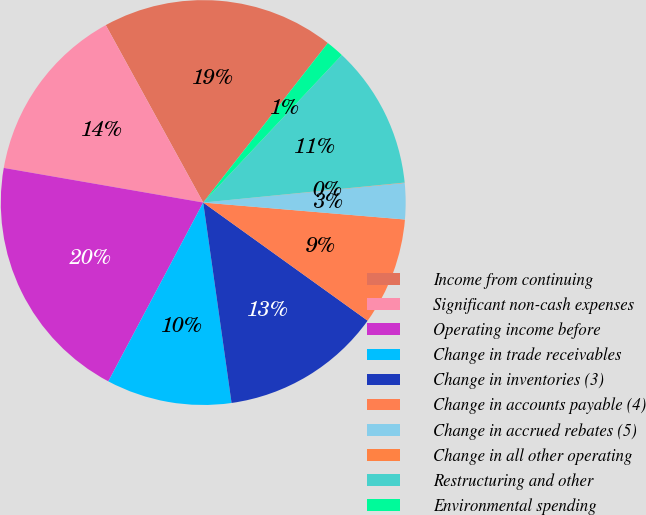Convert chart. <chart><loc_0><loc_0><loc_500><loc_500><pie_chart><fcel>Income from continuing<fcel>Significant non-cash expenses<fcel>Operating income before<fcel>Change in trade receivables<fcel>Change in inventories (3)<fcel>Change in accounts payable (4)<fcel>Change in accrued rebates (5)<fcel>Change in all other operating<fcel>Restructuring and other<fcel>Environmental spending<nl><fcel>18.55%<fcel>14.27%<fcel>19.97%<fcel>10.0%<fcel>12.85%<fcel>8.58%<fcel>2.88%<fcel>0.03%<fcel>11.42%<fcel>1.45%<nl></chart> 